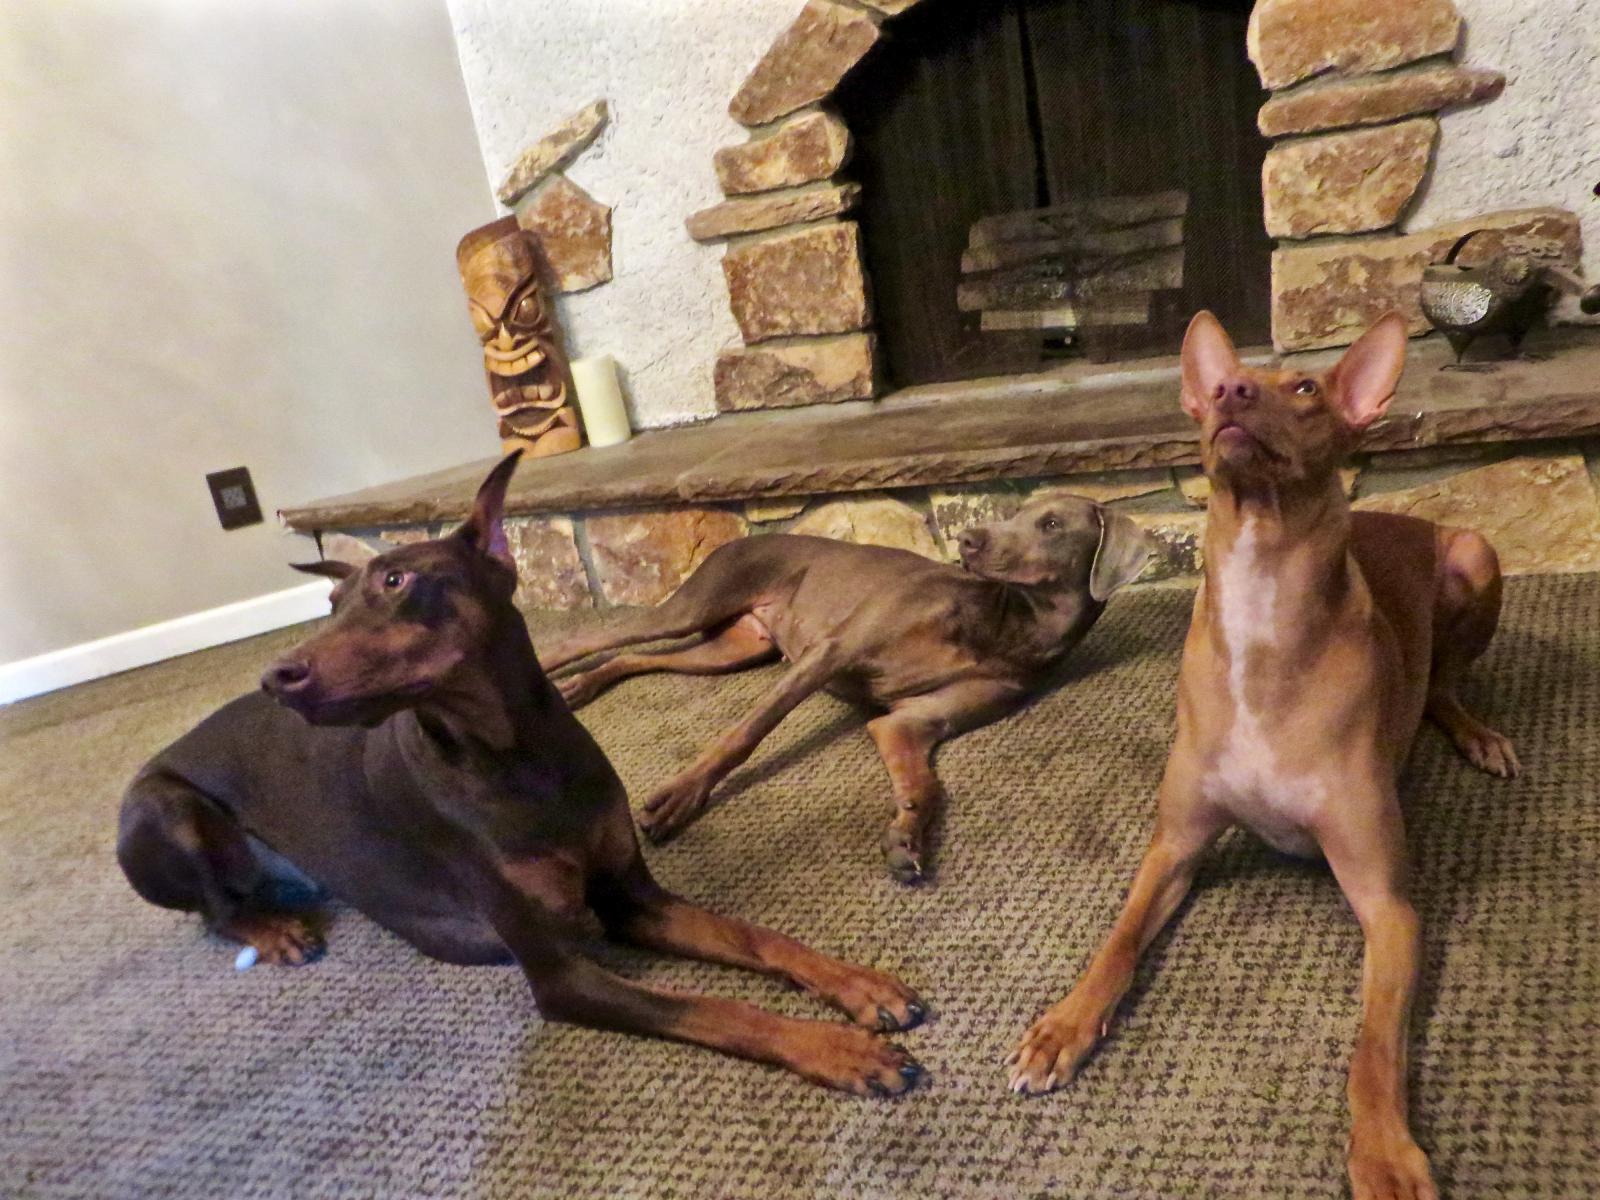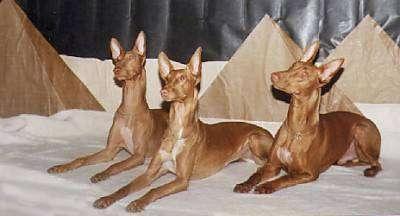The first image is the image on the left, the second image is the image on the right. Assess this claim about the two images: "All the dogs are laying down.". Correct or not? Answer yes or no. Yes. 